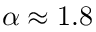Convert formula to latex. <formula><loc_0><loc_0><loc_500><loc_500>\alpha \approx 1 . 8</formula> 